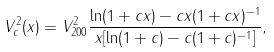Convert formula to latex. <formula><loc_0><loc_0><loc_500><loc_500>V _ { c } ^ { 2 } ( x ) = V _ { 2 0 0 } ^ { 2 } \frac { \ln ( 1 + c x ) - c x ( 1 + c x ) ^ { - 1 } } { x [ \ln ( 1 + c ) - c ( 1 + c ) ^ { - 1 } ] } ,</formula> 